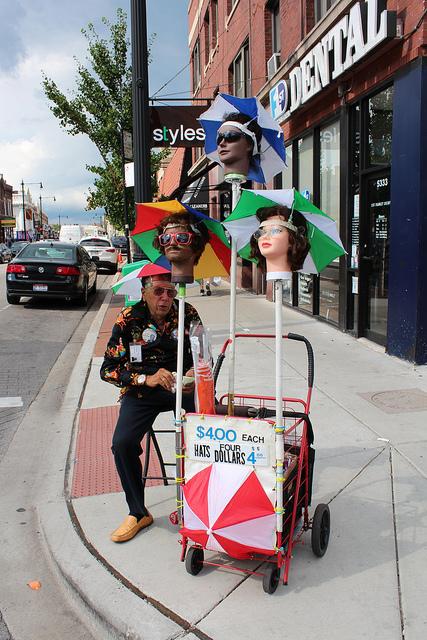What kind of car is this?
Answer briefly. 4 wheeled. Are all of the heads attached to bodies?
Write a very short answer. No. Do the umbrellas have a pattern?
Answer briefly. Yes. 